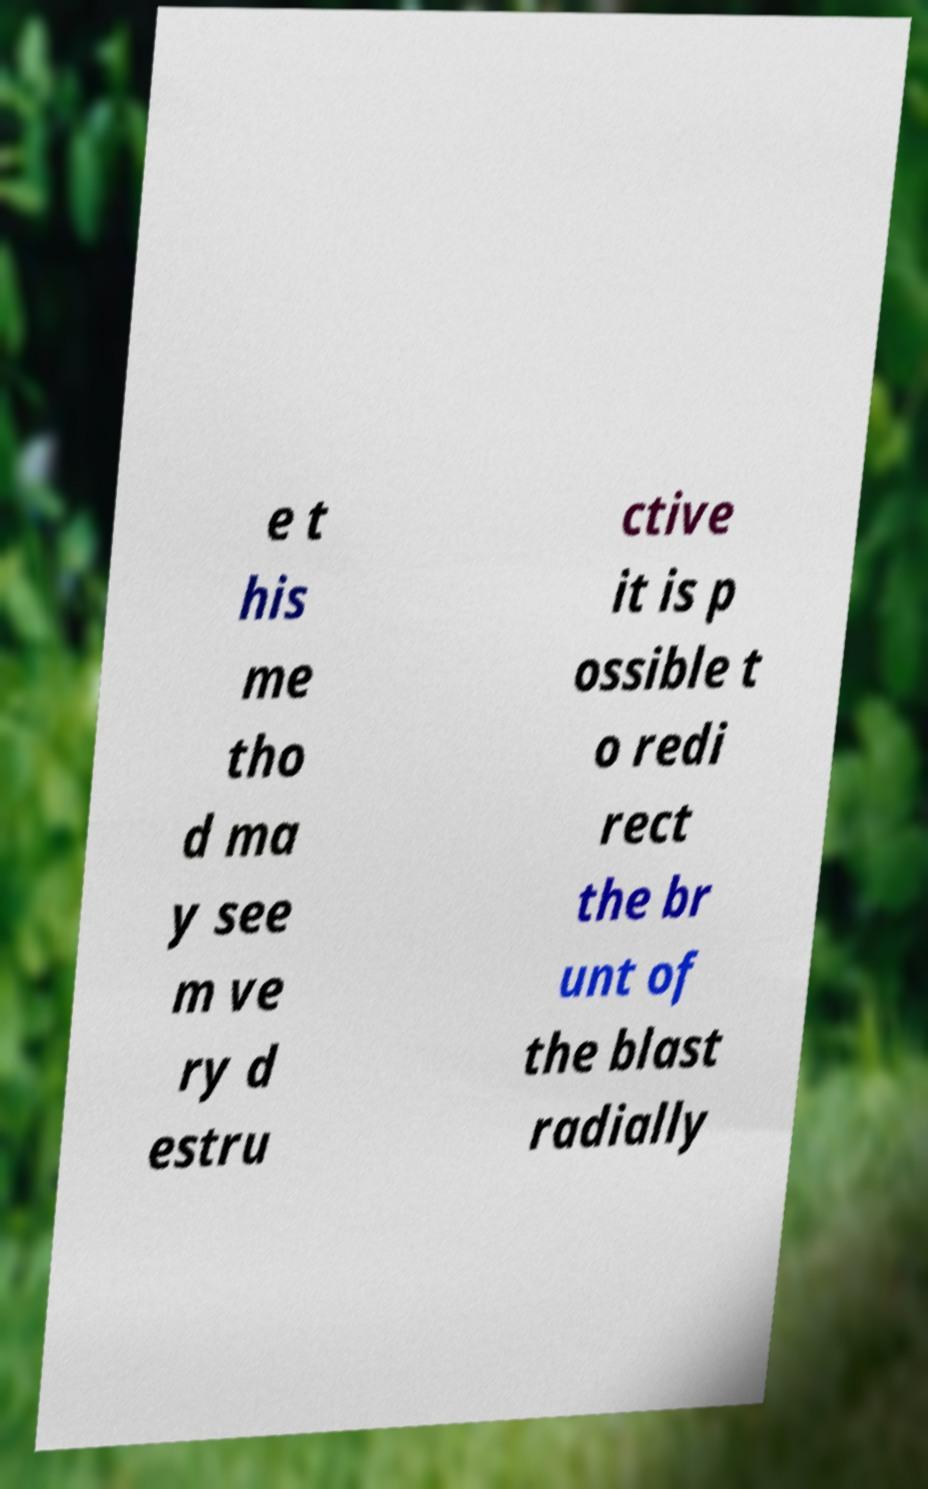Please read and relay the text visible in this image. What does it say? e t his me tho d ma y see m ve ry d estru ctive it is p ossible t o redi rect the br unt of the blast radially 